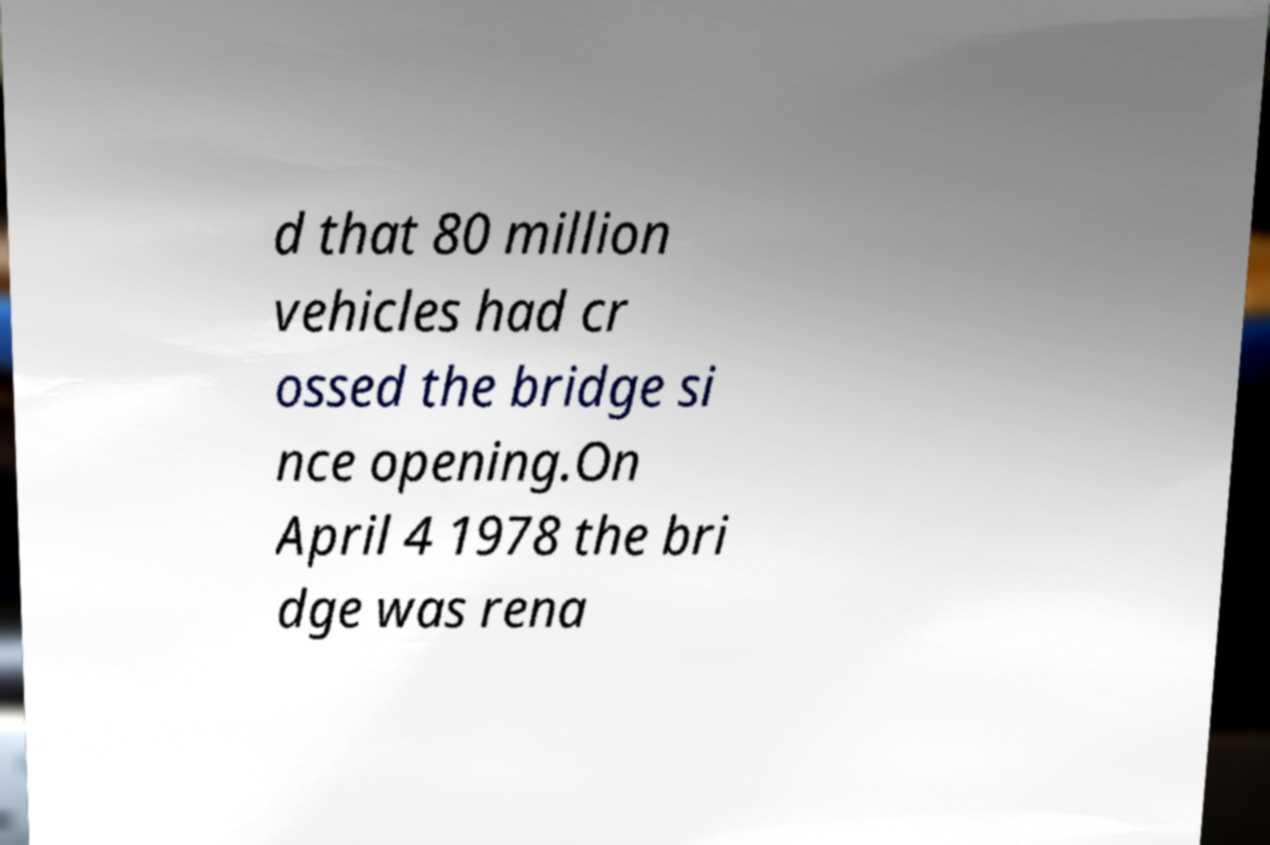What messages or text are displayed in this image? I need them in a readable, typed format. d that 80 million vehicles had cr ossed the bridge si nce opening.On April 4 1978 the bri dge was rena 